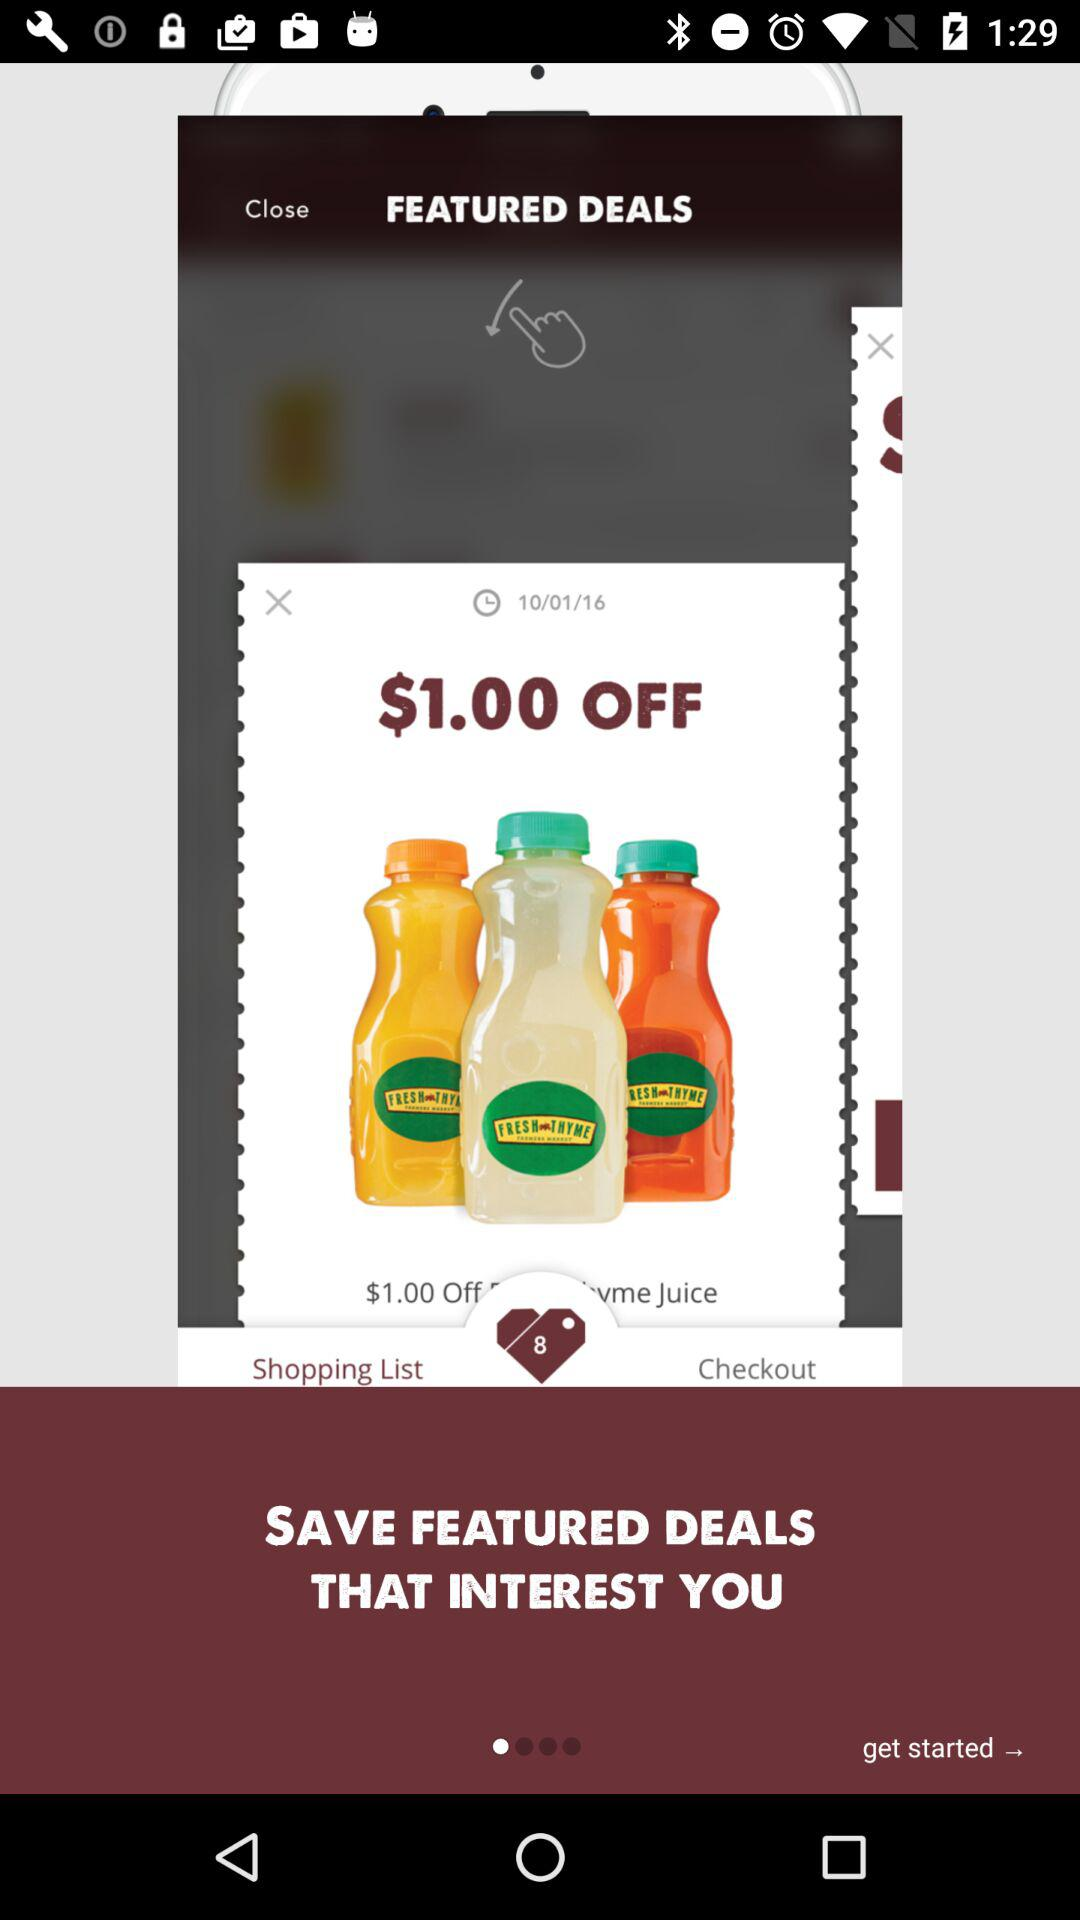How many dollars off is the vme Juice deal?
Answer the question using a single word or phrase. $1.00 